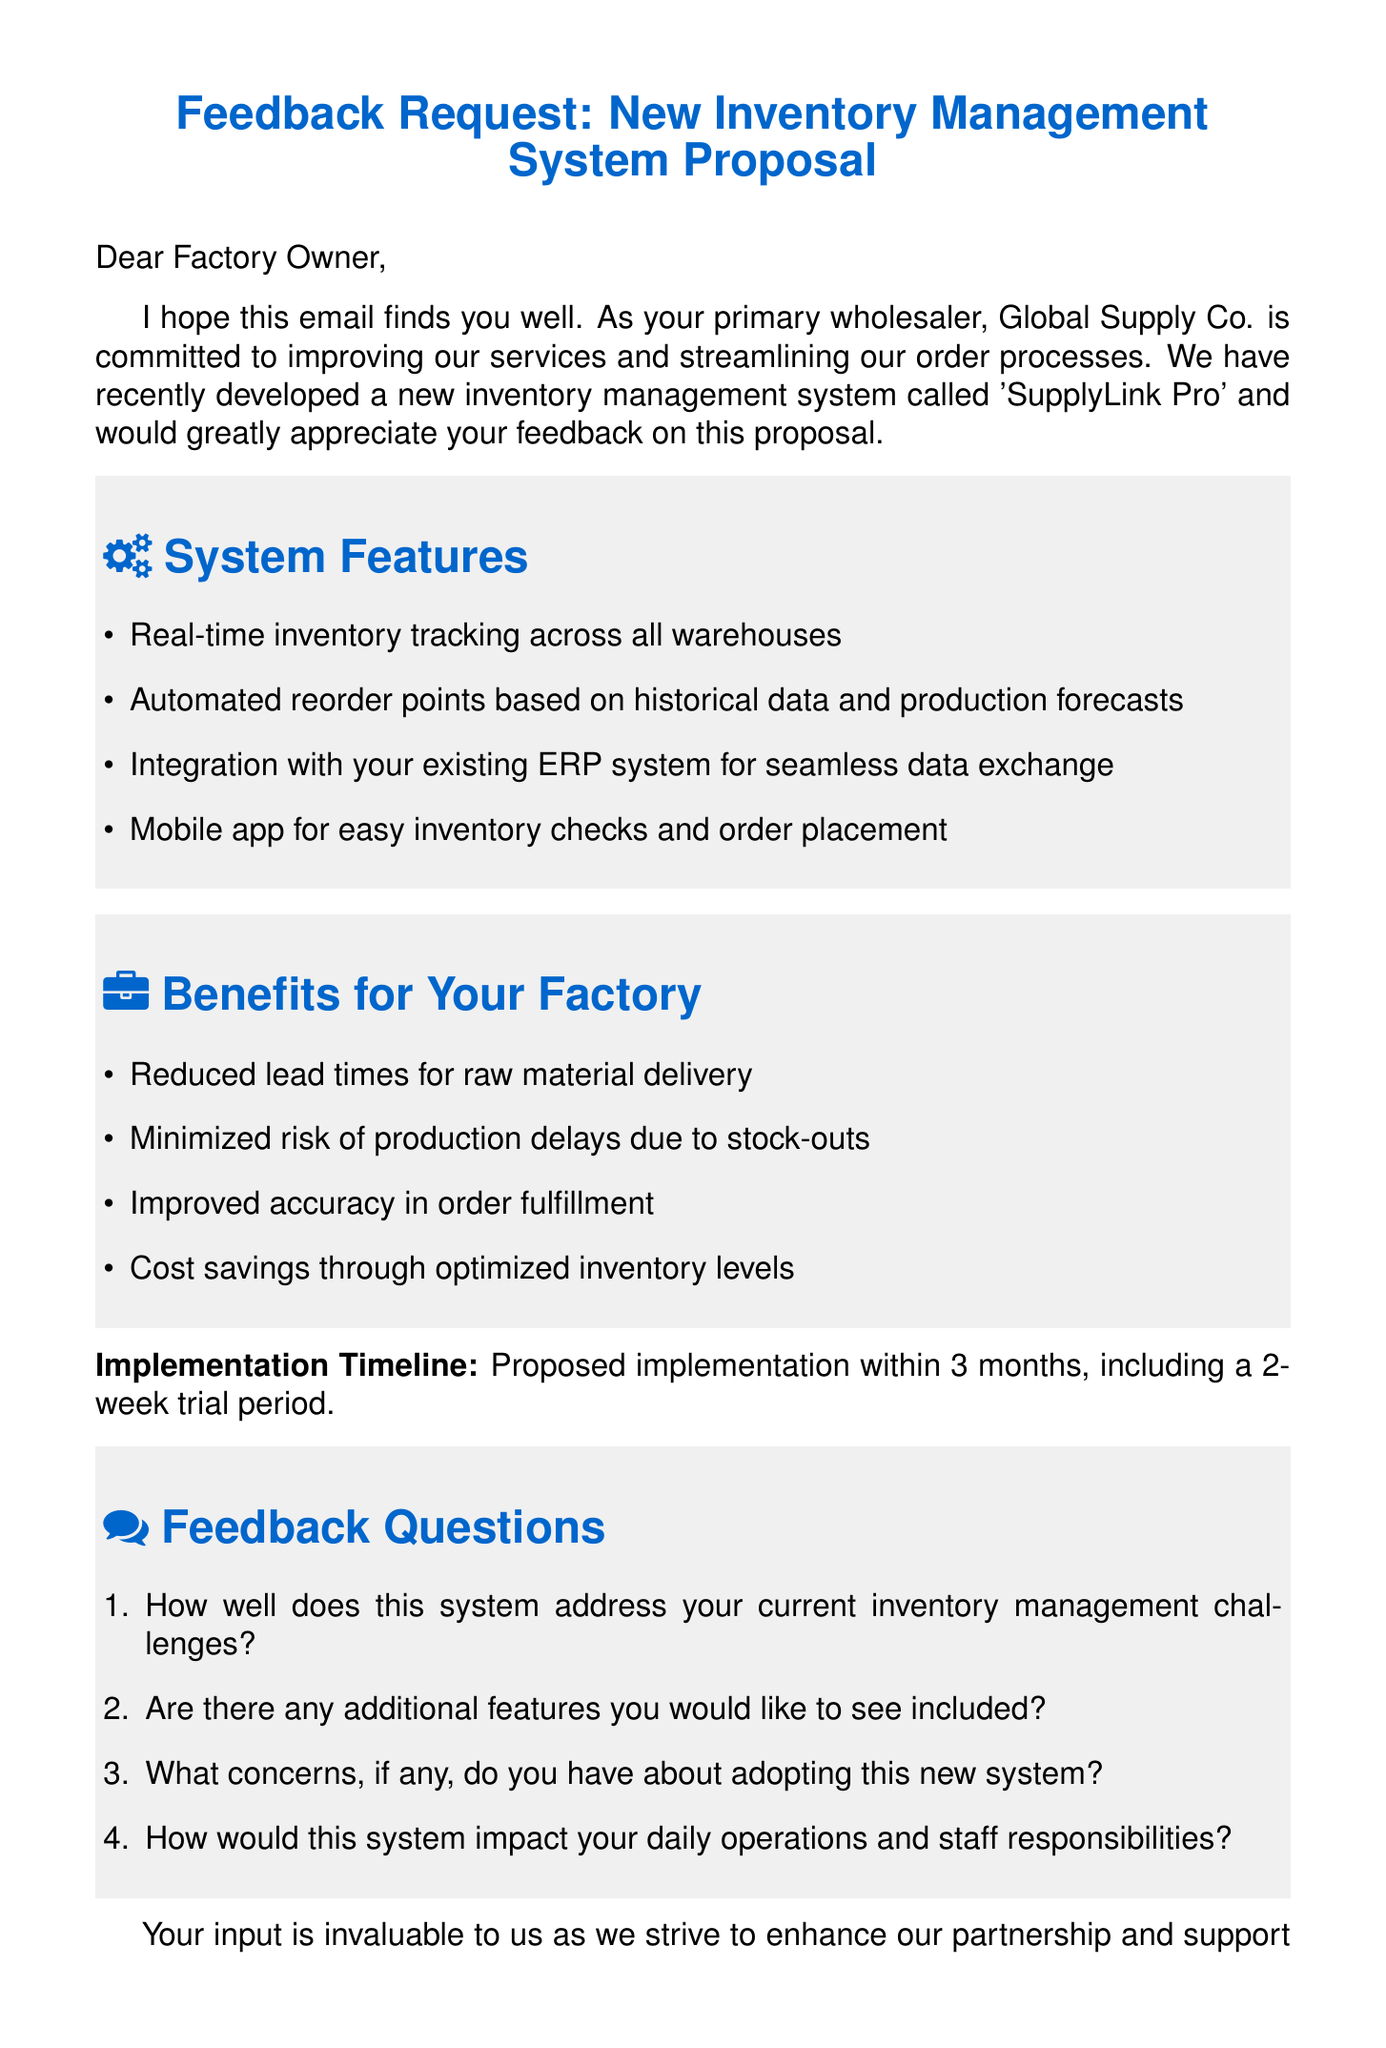What is the name of the new inventory management system? The name of the new inventory management system proposed by Global Supply Co. is 'SupplyLink Pro'.
Answer: 'SupplyLink Pro' What is the proposed implementation timeline? The proposed implementation timeline for the new inventory management system is within 3 months, including a 2-week trial period.
Answer: within 3 months, including a 2-week trial period What is one feature of the system? One feature of the system is real-time inventory tracking across all warehouses.
Answer: real-time inventory tracking across all warehouses What is one benefit for the factory? One benefit for the factory is reduced lead times for raw material delivery.
Answer: reduced lead times for raw material delivery How many feedback questions are listed in the document? The document lists four feedback questions.
Answer: four What does the wholesaler want from the factory owner? The wholesaler wants feedback on the new inventory management system proposal.
Answer: feedback Who is the sender of the email? The sender of the email is John Smith, the Account Manager at Global Supply Co.
Answer: John Smith What type of email is this? This email is a feedback request regarding a new inventory management system proposal.
Answer: feedback request 